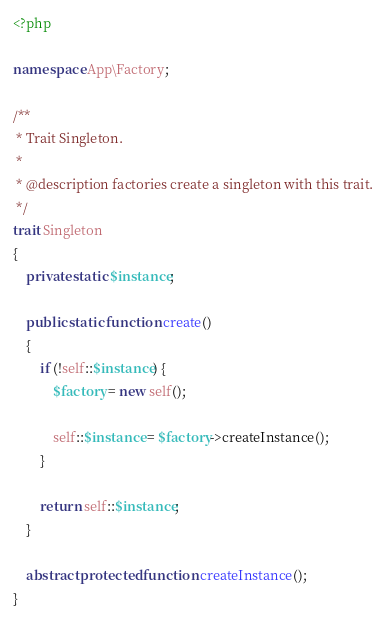<code> <loc_0><loc_0><loc_500><loc_500><_PHP_><?php

namespace App\Factory;

/**
 * Trait Singleton.
 *
 * @description factories create a singleton with this trait.
 */
trait Singleton
{
    private static $instance;

    public static function create()
    {
        if (!self::$instance) {
            $factory = new self();

            self::$instance = $factory->createInstance();
        }

        return self::$instance;
    }

    abstract protected function createInstance();
}
</code> 